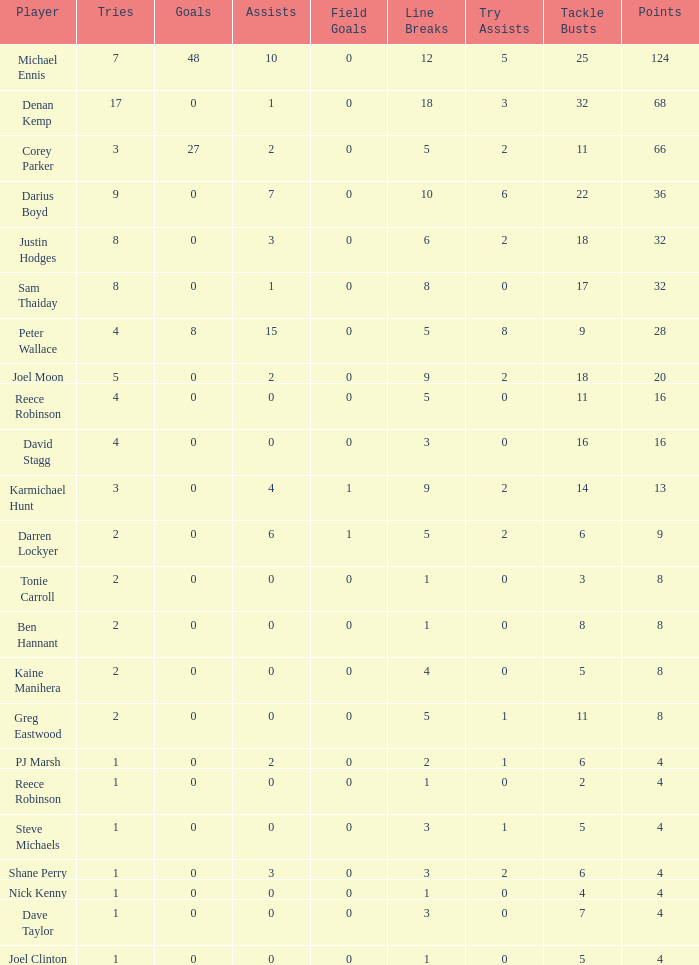How many goals did the player with less than 4 points have? 0.0. 